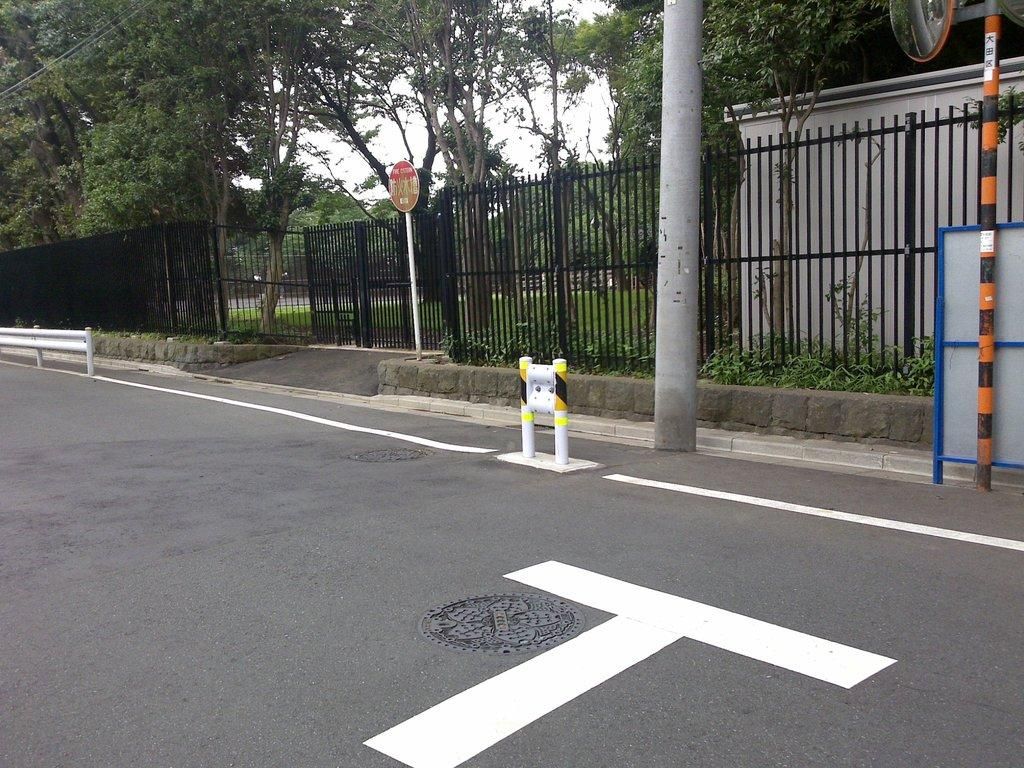What is located at the bottom of the image? There is a road at the bottom of the image. What can be seen in the middle of the image? There are trees, poles, railing, plants, and other objects in the middle of the image. What type of vegetation is present in the background of the image? There are trees in the background of the image. What else can be seen in the background of the image? The sky is visible in the background of the image. Can you tell me how many corks are attached to the trees in the image? There are no corks present in the image; it features a road, trees, poles, railing, plants, and other objects in the middle, as well as grass, trees, and the sky in the background. 